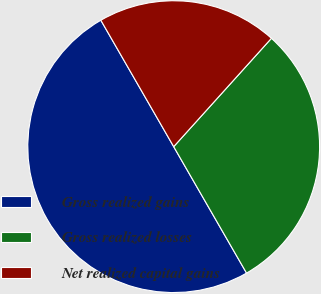Convert chart. <chart><loc_0><loc_0><loc_500><loc_500><pie_chart><fcel>Gross realized gains<fcel>Gross realized losses<fcel>Net realized capital gains<nl><fcel>50.0%<fcel>30.0%<fcel>20.0%<nl></chart> 